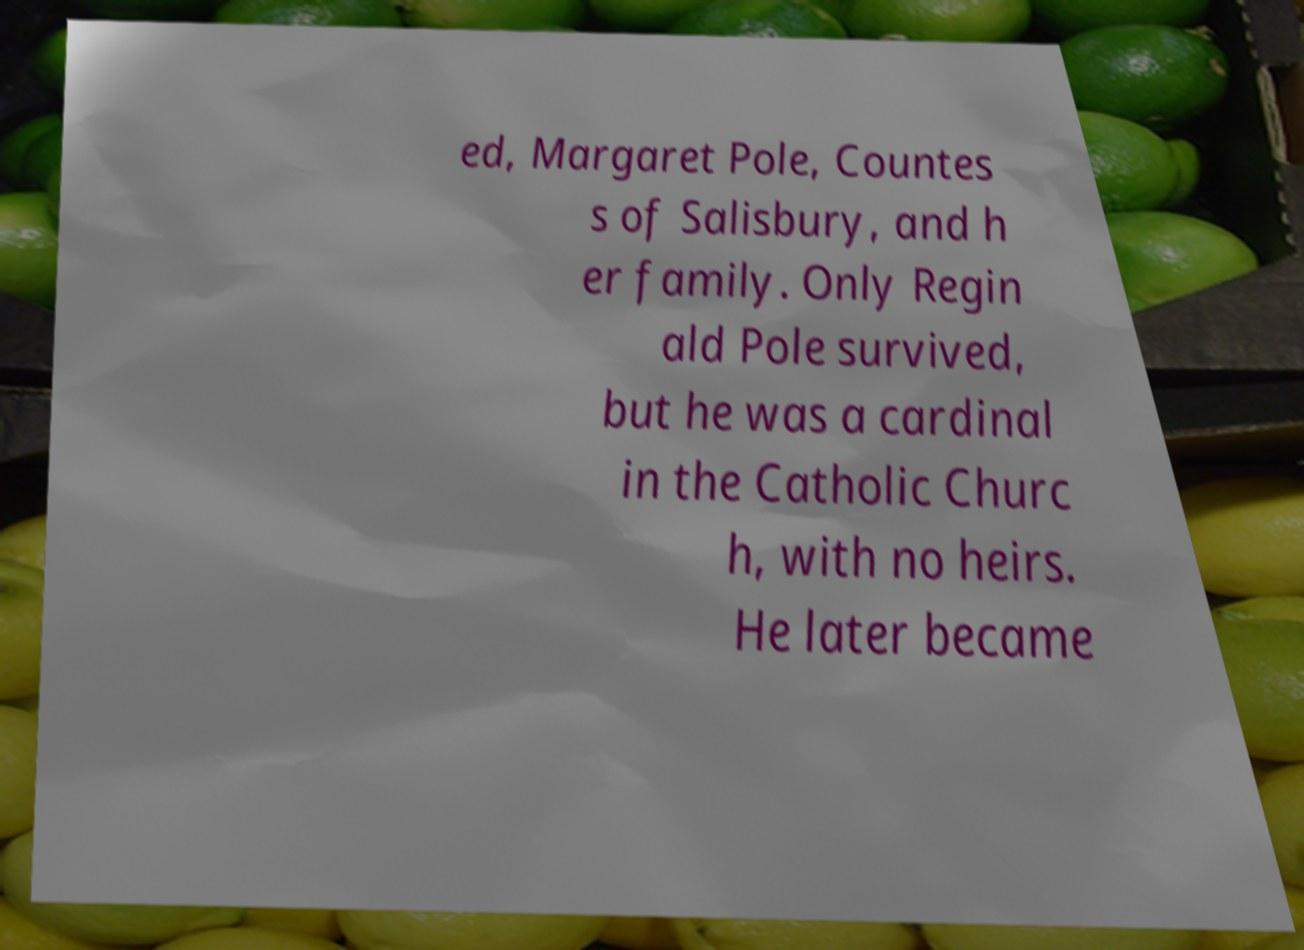Could you extract and type out the text from this image? ed, Margaret Pole, Countes s of Salisbury, and h er family. Only Regin ald Pole survived, but he was a cardinal in the Catholic Churc h, with no heirs. He later became 